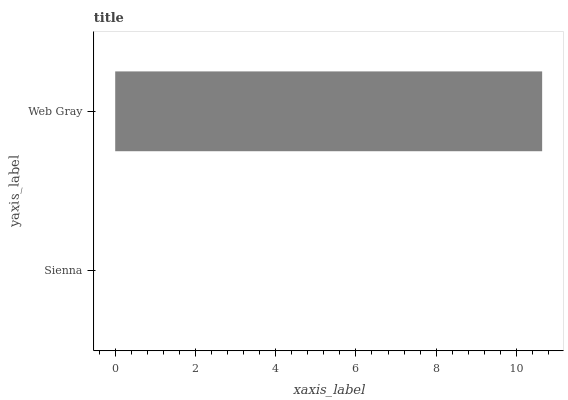Is Sienna the minimum?
Answer yes or no. Yes. Is Web Gray the maximum?
Answer yes or no. Yes. Is Web Gray the minimum?
Answer yes or no. No. Is Web Gray greater than Sienna?
Answer yes or no. Yes. Is Sienna less than Web Gray?
Answer yes or no. Yes. Is Sienna greater than Web Gray?
Answer yes or no. No. Is Web Gray less than Sienna?
Answer yes or no. No. Is Web Gray the high median?
Answer yes or no. Yes. Is Sienna the low median?
Answer yes or no. Yes. Is Sienna the high median?
Answer yes or no. No. Is Web Gray the low median?
Answer yes or no. No. 